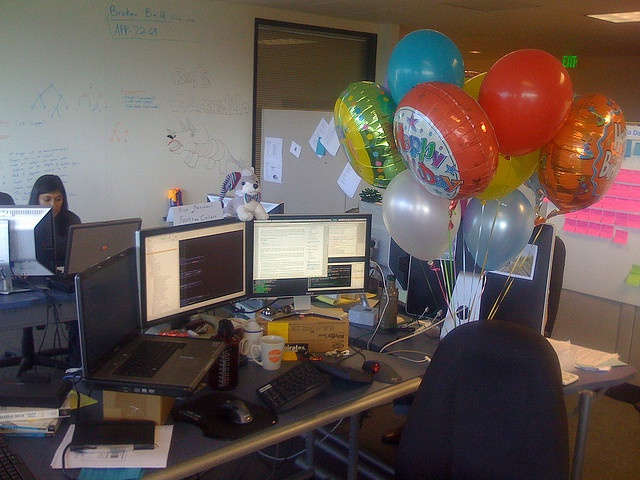Describe the objects in this image and their specific colors. I can see chair in gray, black, maroon, and tan tones, laptop in gray and black tones, tv in gray, black, and darkgray tones, tv in gray, beige, and black tones, and tv in gray, black, and tan tones in this image. 